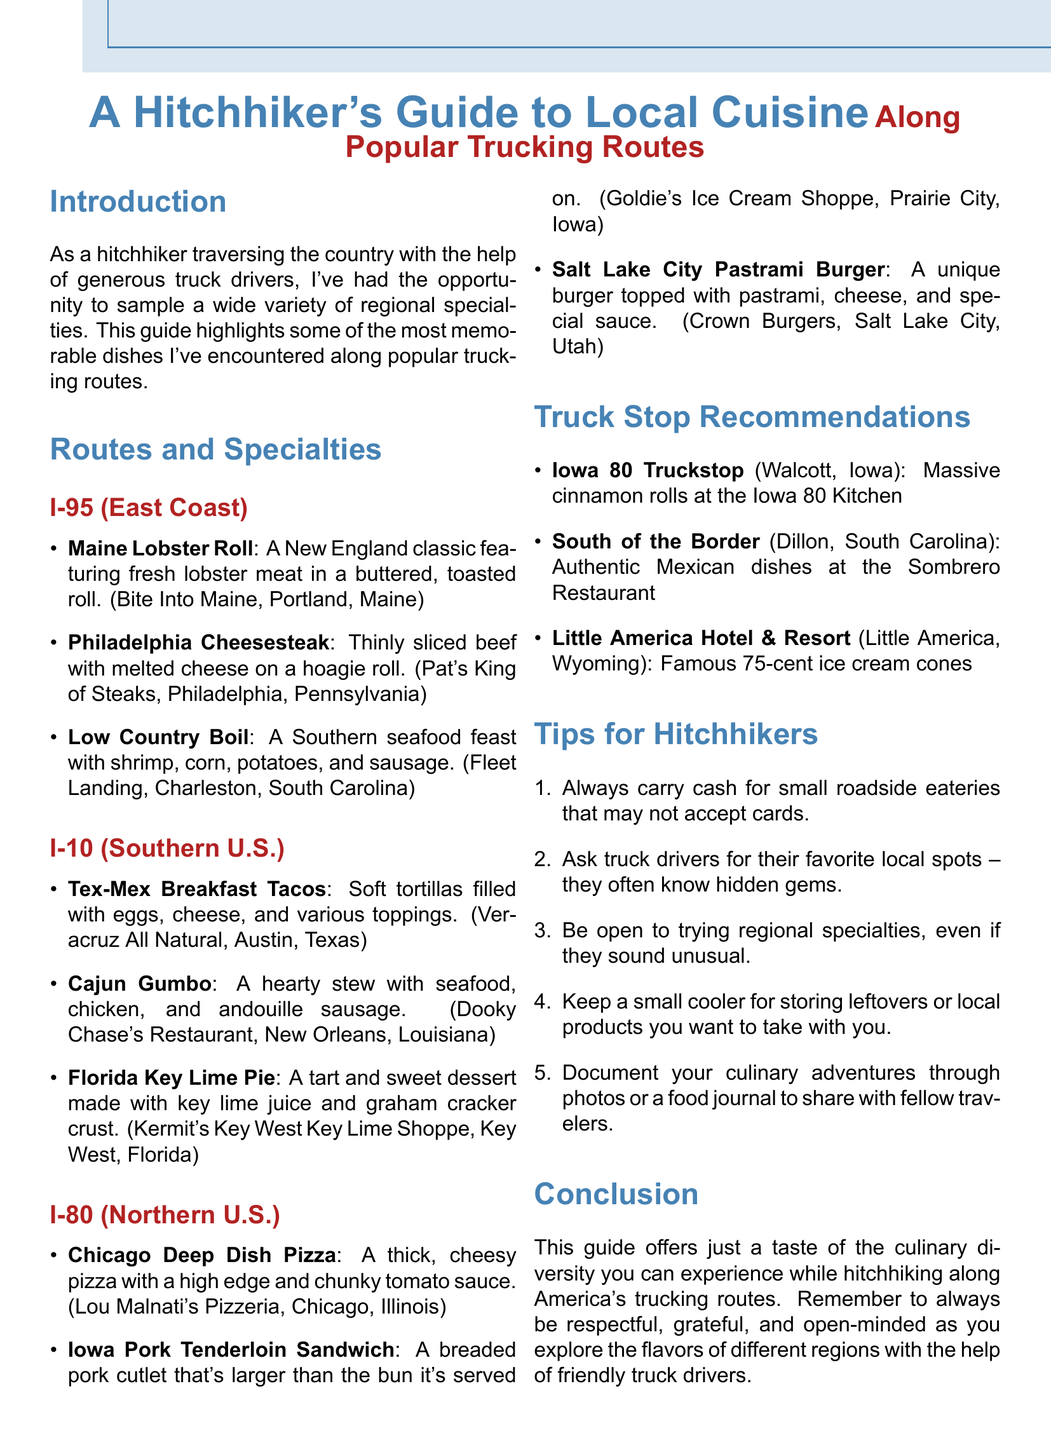What is the title of the document? The title is presented at the top of the document as a main heading.
Answer: A Hitchhiker's Guide to Local Cuisine Along Popular Trucking Routes Which dish is recommended on I-10 in Austin, Texas? The document lists specific dishes according to the routes; Austin's dish is mentioned under I-10.
Answer: Tex-Mex Breakfast Tacos What is the location of the Iowa 80 Truckstop? The document specifies locations for each truck stop mentioned.
Answer: Walcott, Iowa How many tips for hitchhikers are listed in the document? The tips section contains a numbered list which can be counted for the total.
Answer: Five Which dish features shrimp, corn, potatoes, and sausage? The description of the dish in the I-95 section will provide the answer.
Answer: Low Country Boil What is the specialty at Little America Hotel & Resort? The document provides information about specialties at various truck stops.
Answer: Famous 75-cent ice cream cones What route features Chicago Deep Dish Pizza? The document categorizes dishes by route, making it easy to identify where the pizza is located.
Answer: I-80 (Northern U.S.) Which two dishes are served in New Orleans, Louisiana? The document lists dishes under the I-10 route, specifying New Orleans.
Answer: Cajun Gumbo, Florida Key Lime Pie 